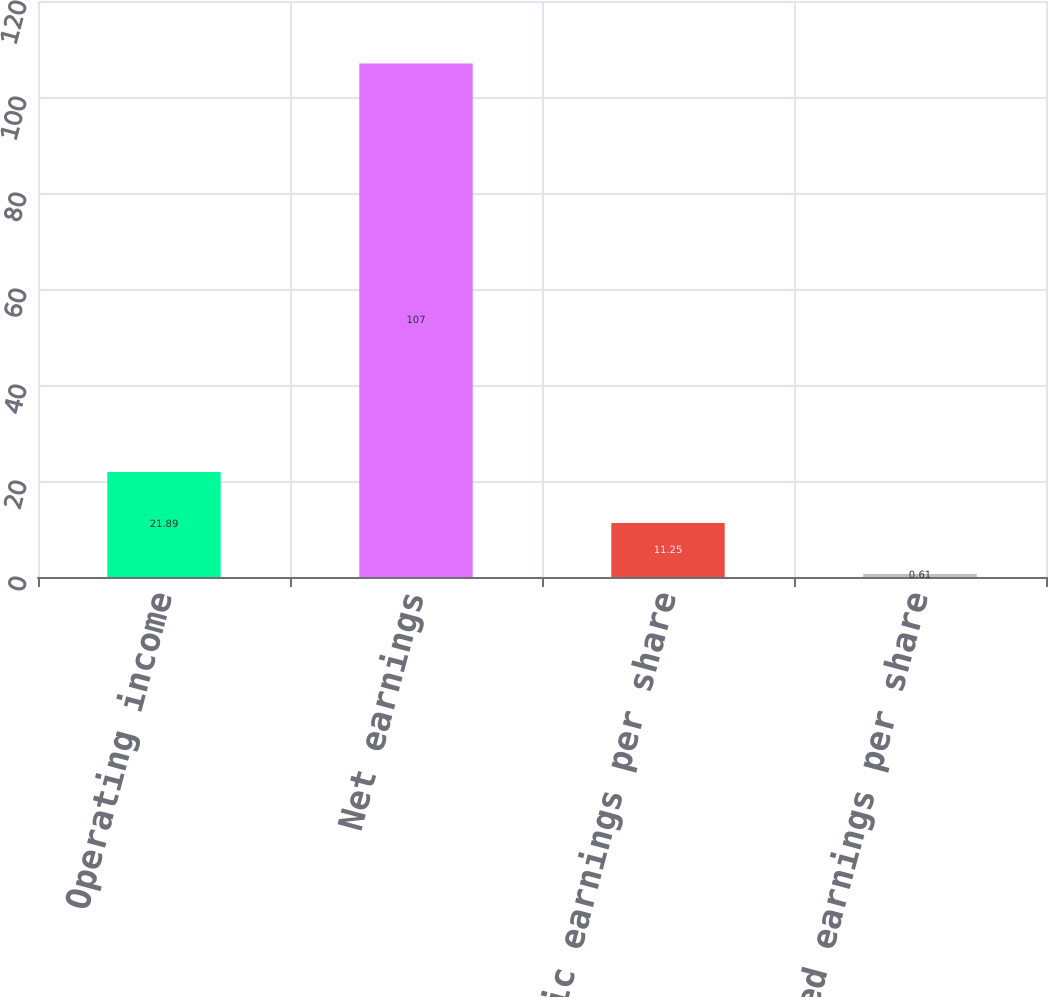Convert chart to OTSL. <chart><loc_0><loc_0><loc_500><loc_500><bar_chart><fcel>Operating income<fcel>Net earnings<fcel>Basic earnings per share<fcel>Diluted earnings per share<nl><fcel>21.89<fcel>107<fcel>11.25<fcel>0.61<nl></chart> 